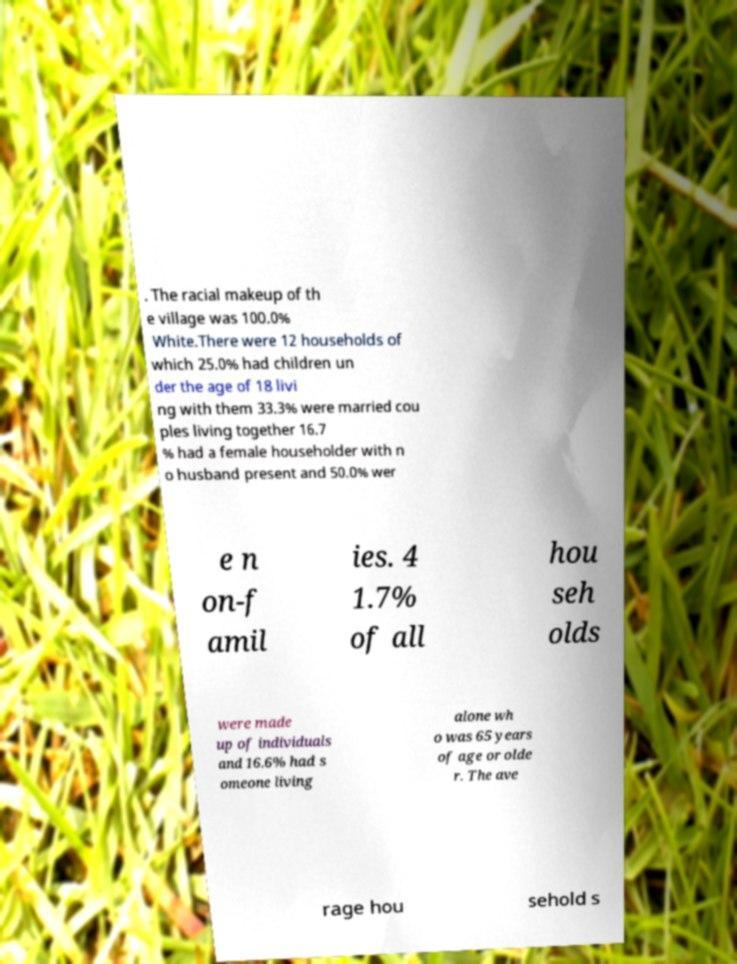Please read and relay the text visible in this image. What does it say? . The racial makeup of th e village was 100.0% White.There were 12 households of which 25.0% had children un der the age of 18 livi ng with them 33.3% were married cou ples living together 16.7 % had a female householder with n o husband present and 50.0% wer e n on-f amil ies. 4 1.7% of all hou seh olds were made up of individuals and 16.6% had s omeone living alone wh o was 65 years of age or olde r. The ave rage hou sehold s 